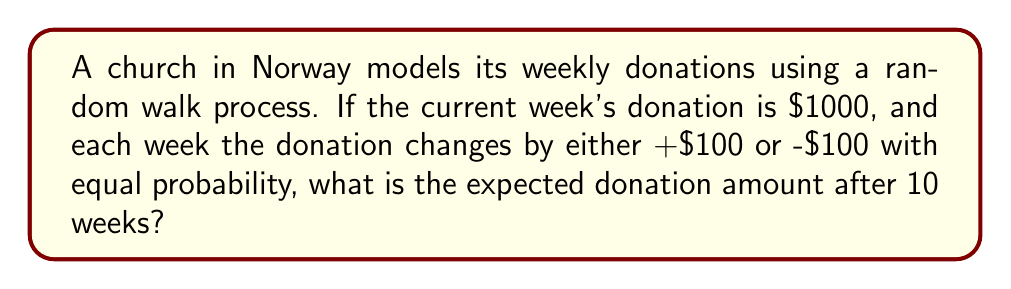Can you solve this math problem? Let's approach this step-by-step:

1) In a random walk process, the expected value after n steps is equal to the initial value. This is because each step has an equal probability of moving up or down by the same amount.

2) Mathematically, we can express this as:

   $$E[X_n] = X_0$$

   where $X_n$ is the value after n steps and $X_0$ is the initial value.

3) In this case:
   - $X_0 = 1000$ (initial donation)
   - n = 10 (number of weeks)

4) The fact that each week the donation changes by +$100 or -$100 with equal probability doesn't affect the expected value. These changes cancel out on average.

5) Therefore, the expected donation amount after 10 weeks is the same as the initial amount:

   $$E[X_{10}] = X_0 = 1000$$

6) It's important to note that while this is the expected value, the actual donation after 10 weeks could be different due to the random nature of the process. The variance of the donation amount would increase over time, even though the expected value remains constant.
Answer: $1000 